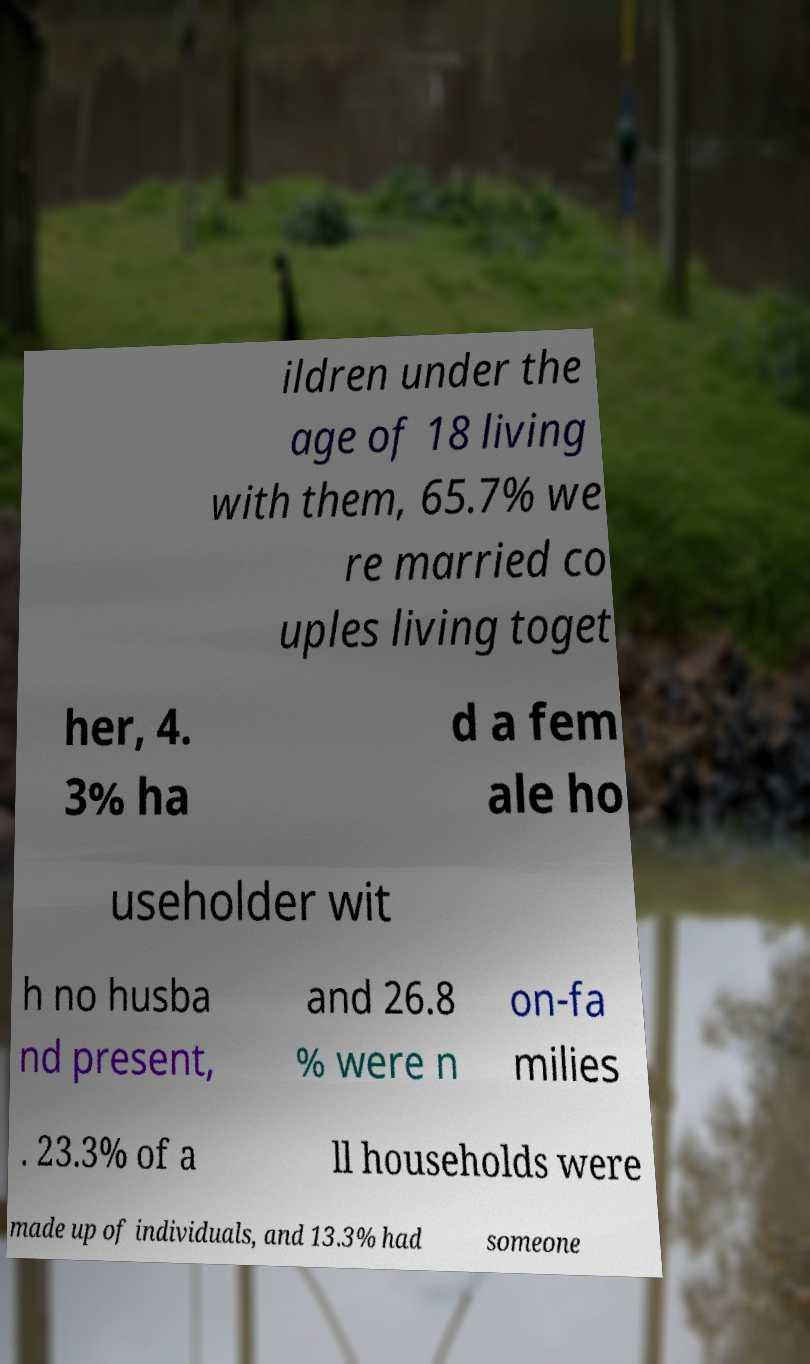There's text embedded in this image that I need extracted. Can you transcribe it verbatim? ildren under the age of 18 living with them, 65.7% we re married co uples living toget her, 4. 3% ha d a fem ale ho useholder wit h no husba nd present, and 26.8 % were n on-fa milies . 23.3% of a ll households were made up of individuals, and 13.3% had someone 